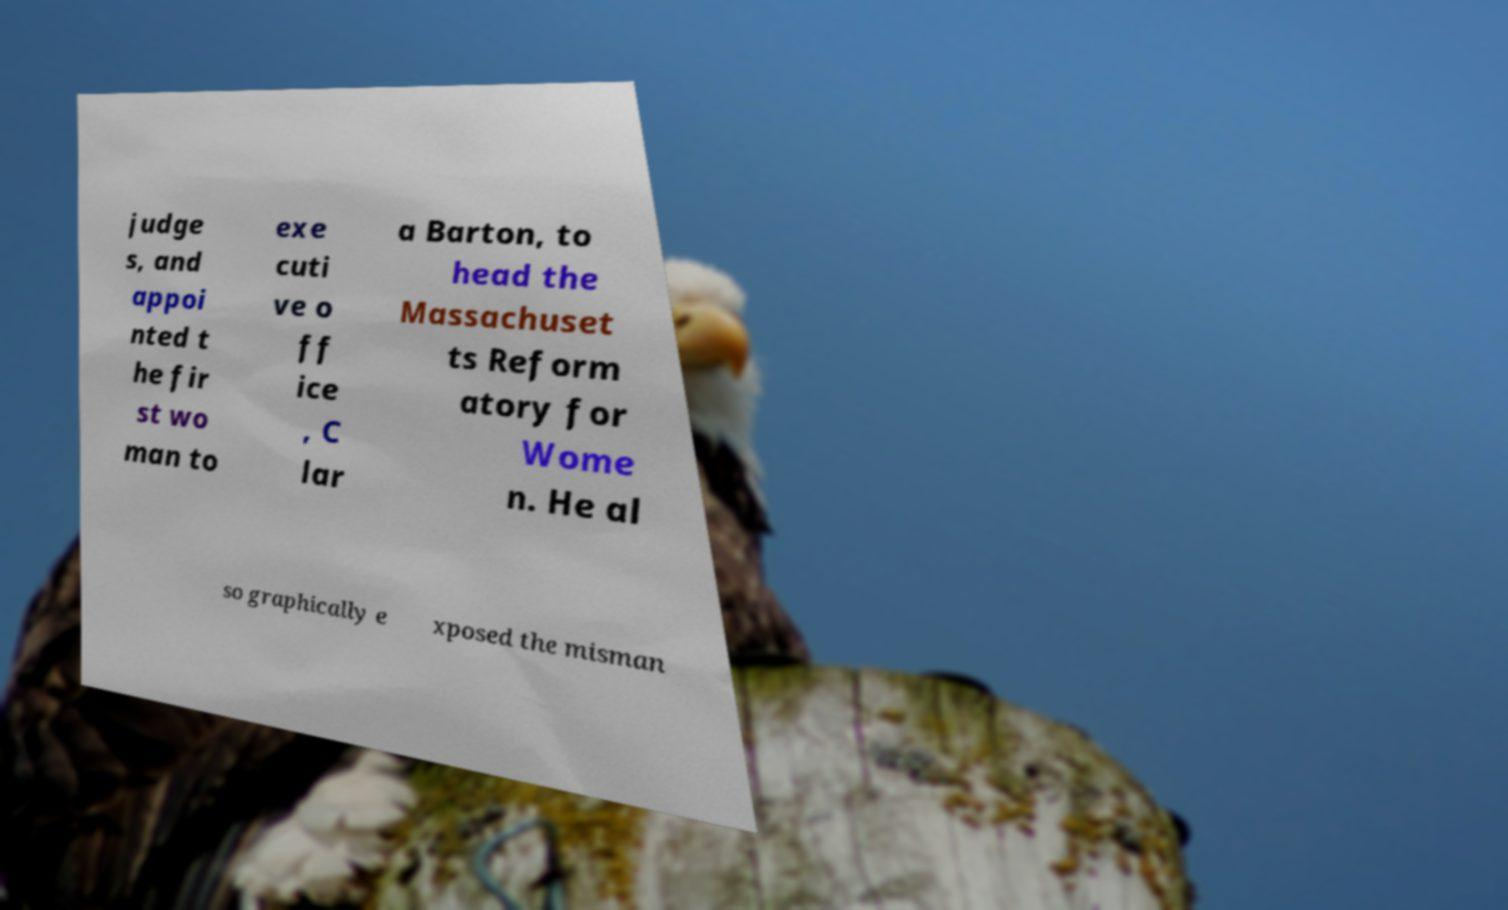Could you assist in decoding the text presented in this image and type it out clearly? judge s, and appoi nted t he fir st wo man to exe cuti ve o ff ice , C lar a Barton, to head the Massachuset ts Reform atory for Wome n. He al so graphically e xposed the misman 